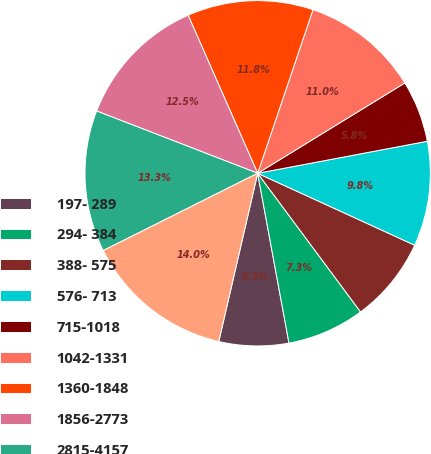<chart> <loc_0><loc_0><loc_500><loc_500><pie_chart><fcel>197- 289<fcel>294- 384<fcel>388- 575<fcel>576- 713<fcel>715-1018<fcel>1042-1331<fcel>1360-1848<fcel>1856-2773<fcel>2815-4157<fcel>4212-5527<nl><fcel>6.52%<fcel>7.26%<fcel>8.0%<fcel>9.81%<fcel>5.79%<fcel>11.05%<fcel>11.79%<fcel>12.53%<fcel>13.26%<fcel>14.0%<nl></chart> 